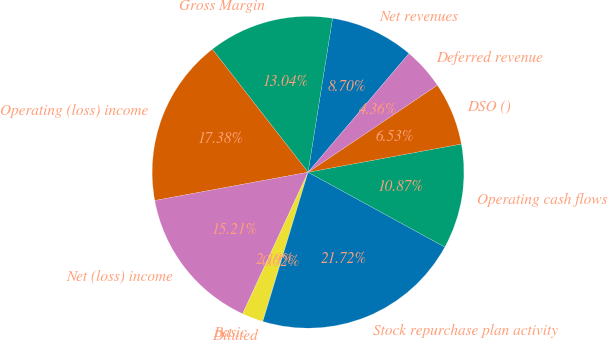<chart> <loc_0><loc_0><loc_500><loc_500><pie_chart><fcel>Net revenues<fcel>Gross Margin<fcel>Operating (loss) income<fcel>Net (loss) income<fcel>Basic<fcel>Diluted<fcel>Stock repurchase plan activity<fcel>Operating cash flows<fcel>DSO ()<fcel>Deferred revenue<nl><fcel>8.7%<fcel>13.04%<fcel>17.38%<fcel>15.21%<fcel>2.19%<fcel>0.02%<fcel>21.72%<fcel>10.87%<fcel>6.53%<fcel>4.36%<nl></chart> 